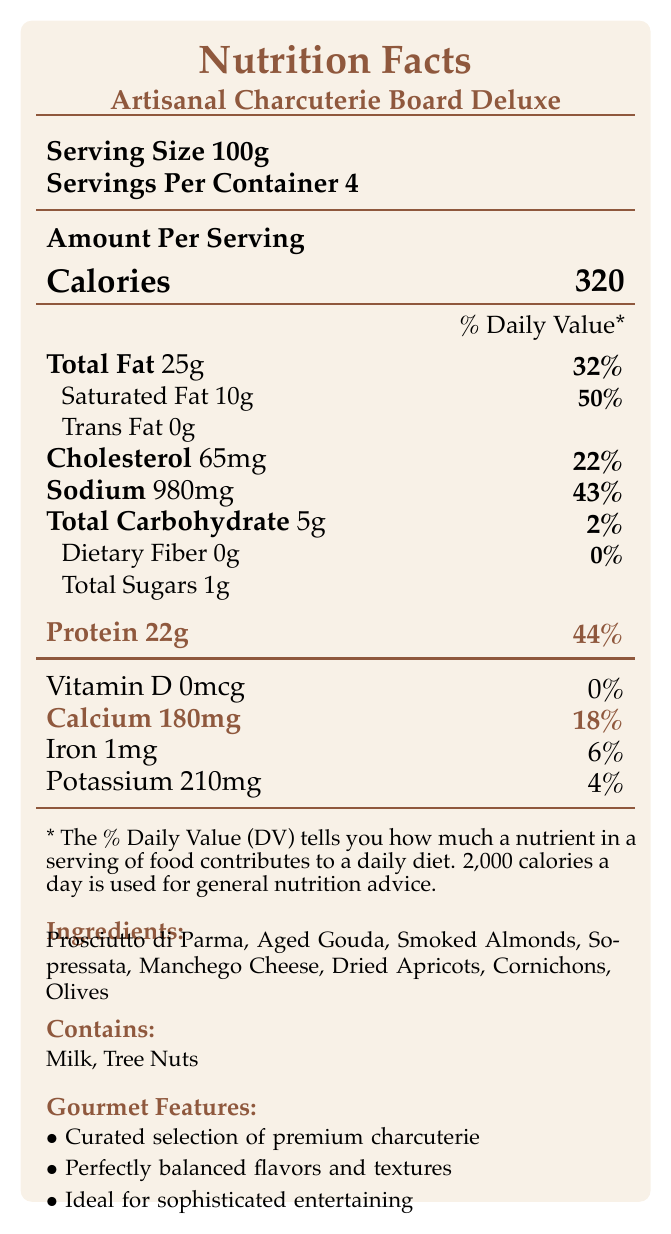what is the serving size? The serving size is explicitly mentioned as 'Serving Size 100g' in the document.
Answer: 100g how many servings are in the container? The document states under 'Servings Per Container' that there are 4 servings.
Answer: 4 how many grams of protein are in one serving? The 'Protein' section of the document lists 22g of protein per serving.
Answer: 22g what percentage of the daily value of calcium does one serving provide? Under 'Calcium,' the document indicates that one serving provides 18% of the daily value.
Answer: 18% which ingredient is used in the charcuterie board that is a tree nut? The ingredient list includes 'Smoked Almonds,' which are tree nuts, as also indicated under allergens.
Answer: Smoked Almonds how many grams of total fat are in one serving? The 'Total Fat' section specifies that there are 25g of total fat in one serving.
Answer: 25g how many calories are in one serving? A. 200 B. 250 C. 320 D. 350 The document specifies that there are 320 calories per serving.
Answer: C what local source provides the meats for this charcuterie board? A. Hillside Farms B. Blue Ridge Creamery C. Sunset Valley Orchards The sourcing information states that the meats are locally sourced from Hillside Farms.
Answer: A is there any trans fat in one serving? The document lists 'Trans Fat 0g', which indicates no trans fat per serving.
Answer: No does this charcuterie board contain any dietary fiber? The 'Dietary Fiber' section lists 0g, indicating that it does not contain dietary fiber.
Answer: No summarize the nutritional highlights of the charcuterie board. The summary encompasses key nutritional values (calories, fat, protein, calcium), as well as highlights from the ingredient and sourcing information, alongside allergen details.
Answer: The Artisanal Charcuterie Board Deluxe provides each serving with 320 calories, 25g of total fat, 22g of protein, and 180mg of calcium. It is a curated selection of premium meats, cheeses, and accompaniments, locally sourced, and contains allergenic ingredients like milk and tree nuts. does the document specify the exact amount of vitamin D in one serving? The document states 'Vitamin D 0mcg', indicating the specific amount per serving.
Answer: Yes how many allergens are mentioned in the document? The allergens section mentions 'Milk' and 'Tree Nuts', totaling two allergens.
Answer: Two can the exact number of olives in the charcuterie board be determined from the document? The ingredient list includes 'Olives,' but it does not specify the quantity.
Answer: Not enough information 